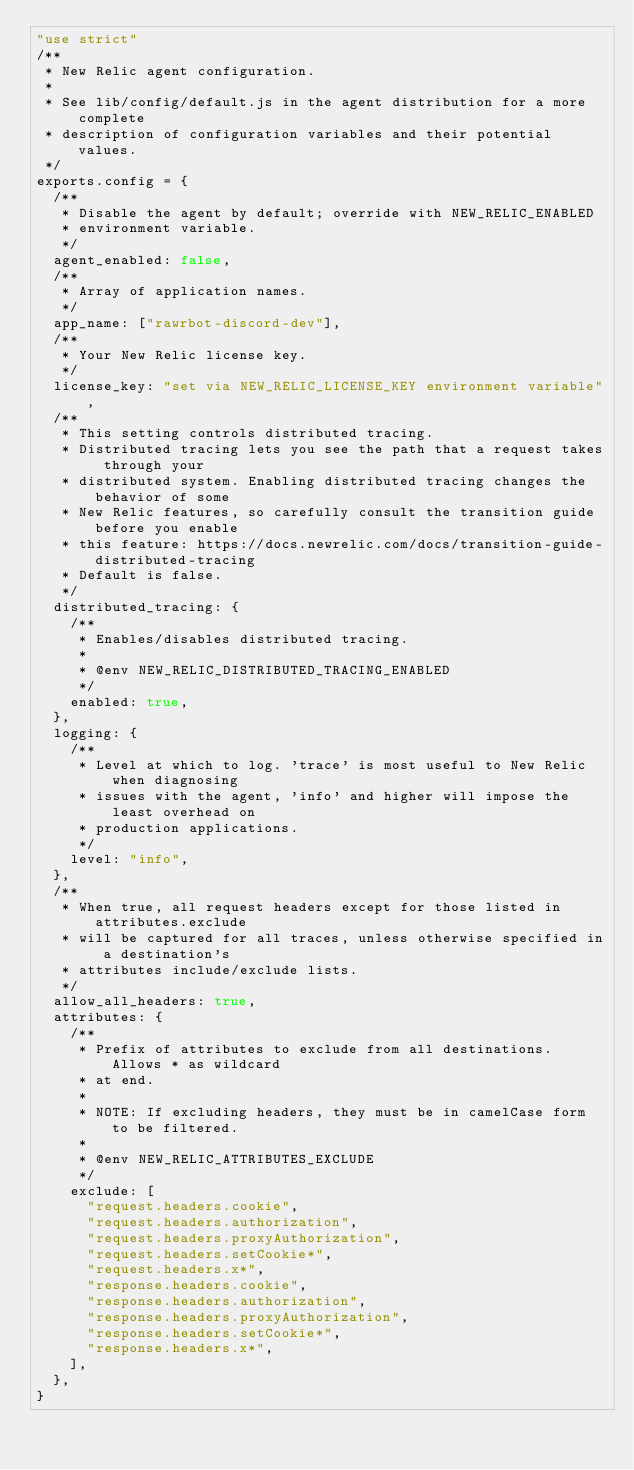Convert code to text. <code><loc_0><loc_0><loc_500><loc_500><_JavaScript_>"use strict"
/**
 * New Relic agent configuration.
 *
 * See lib/config/default.js in the agent distribution for a more complete
 * description of configuration variables and their potential values.
 */
exports.config = {
  /**
   * Disable the agent by default; override with NEW_RELIC_ENABLED
   * environment variable.
   */
  agent_enabled: false,
  /**
   * Array of application names.
   */
  app_name: ["rawrbot-discord-dev"],
  /**
   * Your New Relic license key.
   */
  license_key: "set via NEW_RELIC_LICENSE_KEY environment variable",
  /**
   * This setting controls distributed tracing.
   * Distributed tracing lets you see the path that a request takes through your
   * distributed system. Enabling distributed tracing changes the behavior of some
   * New Relic features, so carefully consult the transition guide before you enable
   * this feature: https://docs.newrelic.com/docs/transition-guide-distributed-tracing
   * Default is false.
   */
  distributed_tracing: {
    /**
     * Enables/disables distributed tracing.
     *
     * @env NEW_RELIC_DISTRIBUTED_TRACING_ENABLED
     */
    enabled: true,
  },
  logging: {
    /**
     * Level at which to log. 'trace' is most useful to New Relic when diagnosing
     * issues with the agent, 'info' and higher will impose the least overhead on
     * production applications.
     */
    level: "info",
  },
  /**
   * When true, all request headers except for those listed in attributes.exclude
   * will be captured for all traces, unless otherwise specified in a destination's
   * attributes include/exclude lists.
   */
  allow_all_headers: true,
  attributes: {
    /**
     * Prefix of attributes to exclude from all destinations. Allows * as wildcard
     * at end.
     *
     * NOTE: If excluding headers, they must be in camelCase form to be filtered.
     *
     * @env NEW_RELIC_ATTRIBUTES_EXCLUDE
     */
    exclude: [
      "request.headers.cookie",
      "request.headers.authorization",
      "request.headers.proxyAuthorization",
      "request.headers.setCookie*",
      "request.headers.x*",
      "response.headers.cookie",
      "response.headers.authorization",
      "response.headers.proxyAuthorization",
      "response.headers.setCookie*",
      "response.headers.x*",
    ],
  },
}
</code> 